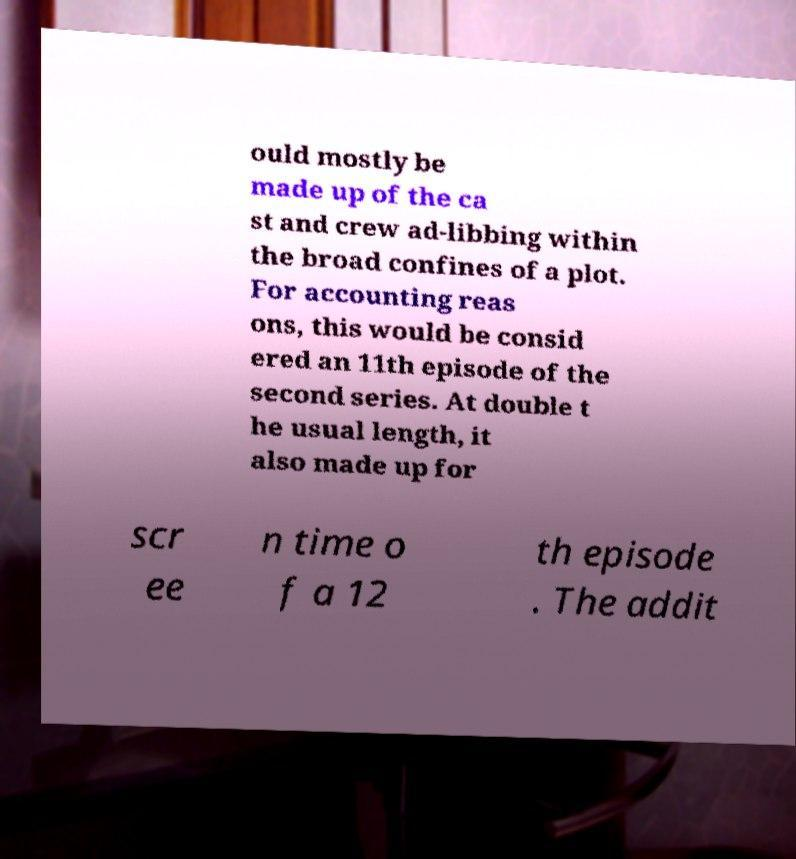Could you extract and type out the text from this image? ould mostly be made up of the ca st and crew ad-libbing within the broad confines of a plot. For accounting reas ons, this would be consid ered an 11th episode of the second series. At double t he usual length, it also made up for scr ee n time o f a 12 th episode . The addit 